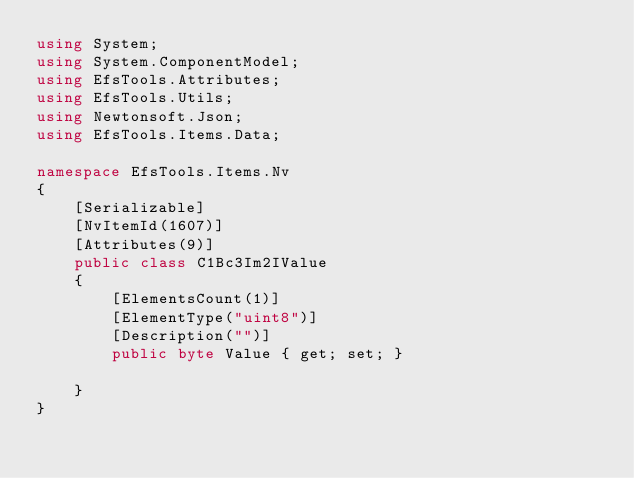Convert code to text. <code><loc_0><loc_0><loc_500><loc_500><_C#_>using System;
using System.ComponentModel;
using EfsTools.Attributes;
using EfsTools.Utils;
using Newtonsoft.Json;
using EfsTools.Items.Data;

namespace EfsTools.Items.Nv
{
    [Serializable]
    [NvItemId(1607)]
    [Attributes(9)]
    public class C1Bc3Im2IValue
    {
        [ElementsCount(1)]
        [ElementType("uint8")]
        [Description("")]
        public byte Value { get; set; }
        
    }
}
</code> 